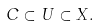<formula> <loc_0><loc_0><loc_500><loc_500>C \subset U \subset X .</formula> 